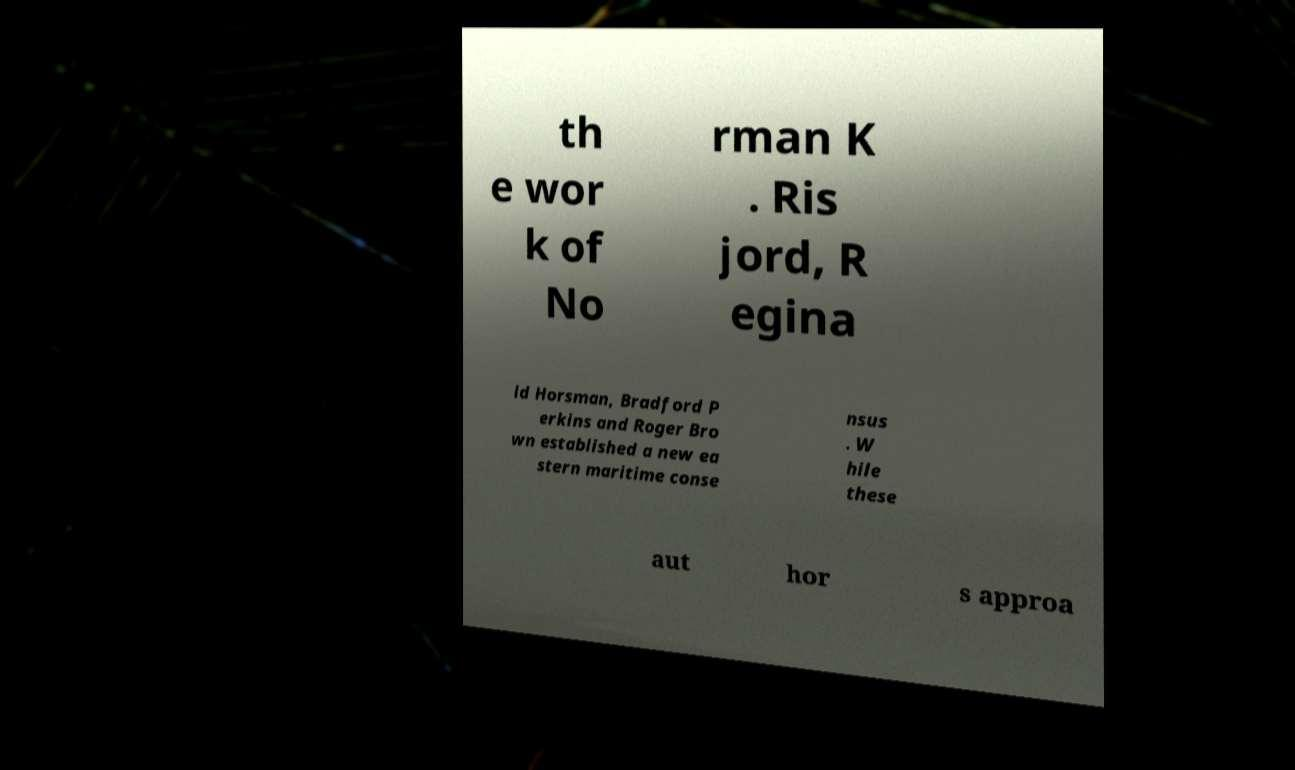I need the written content from this picture converted into text. Can you do that? th e wor k of No rman K . Ris jord, R egina ld Horsman, Bradford P erkins and Roger Bro wn established a new ea stern maritime conse nsus . W hile these aut hor s approa 